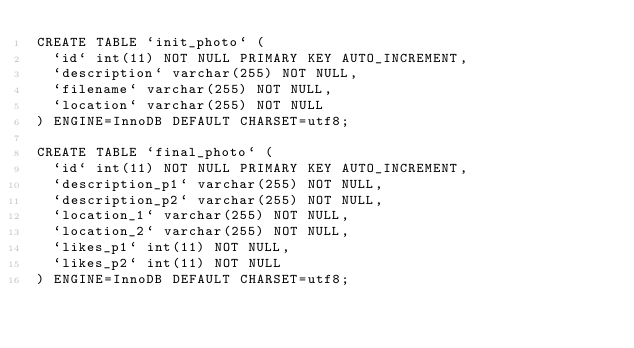Convert code to text. <code><loc_0><loc_0><loc_500><loc_500><_SQL_>CREATE TABLE `init_photo` (
  `id` int(11) NOT NULL PRIMARY KEY AUTO_INCREMENT,
  `description` varchar(255) NOT NULL,
  `filename` varchar(255) NOT NULL,
  `location` varchar(255) NOT NULL
) ENGINE=InnoDB DEFAULT CHARSET=utf8;

CREATE TABLE `final_photo` (
  `id` int(11) NOT NULL PRIMARY KEY AUTO_INCREMENT,
  `description_p1` varchar(255) NOT NULL,
  `description_p2` varchar(255) NOT NULL,
  `location_1` varchar(255) NOT NULL,
  `location_2` varchar(255) NOT NULL,
  `likes_p1` int(11) NOT NULL,
  `likes_p2` int(11) NOT NULL
) ENGINE=InnoDB DEFAULT CHARSET=utf8;
</code> 